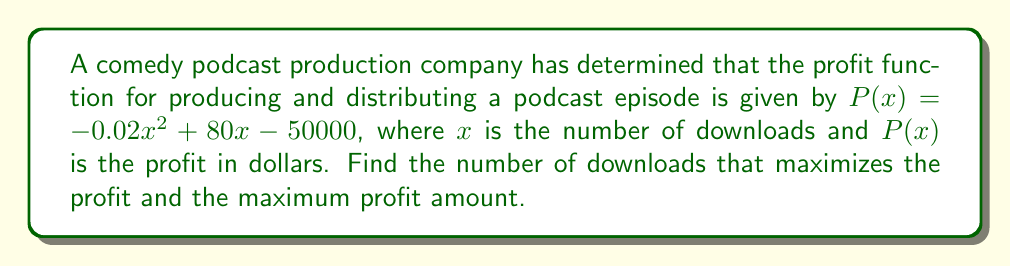Can you answer this question? To find the maximum profit point, we need to follow these steps:

1) The profit function is a quadratic function, and its graph is a parabola that opens downward (because the coefficient of $x^2$ is negative). The maximum point occurs at the vertex of this parabola.

2) For a quadratic function in the form $f(x) = ax^2 + bx + c$, the x-coordinate of the vertex is given by $x = -\frac{b}{2a}$.

3) In our case, $a = -0.02$, $b = 80$, and $c = -50000$. Let's substitute these values:

   $x = -\frac{80}{2(-0.02)} = -\frac{80}{-0.04} = 2000$

4) This means the profit is maximized when there are 2000 downloads.

5) To find the maximum profit, we substitute $x = 2000$ into the original profit function:

   $P(2000) = -0.02(2000)^2 + 80(2000) - 50000$
             $= -0.02(4000000) + 160000 - 50000$
             $= -80000 + 160000 - 50000$
             $= 30000$

Therefore, the maximum profit is $30000.
Answer: 2000 downloads; $30000 